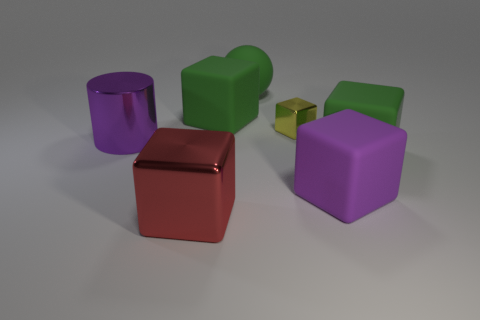Subtract 2 blocks. How many blocks are left? 3 Subtract all yellow blocks. How many blocks are left? 4 Subtract all red blocks. How many blocks are left? 4 Subtract all cyan cubes. Subtract all green cylinders. How many cubes are left? 5 Add 1 tiny yellow blocks. How many objects exist? 8 Subtract all cubes. How many objects are left? 2 Subtract 0 red balls. How many objects are left? 7 Subtract all small yellow things. Subtract all purple rubber cubes. How many objects are left? 5 Add 6 green things. How many green things are left? 9 Add 6 large purple objects. How many large purple objects exist? 8 